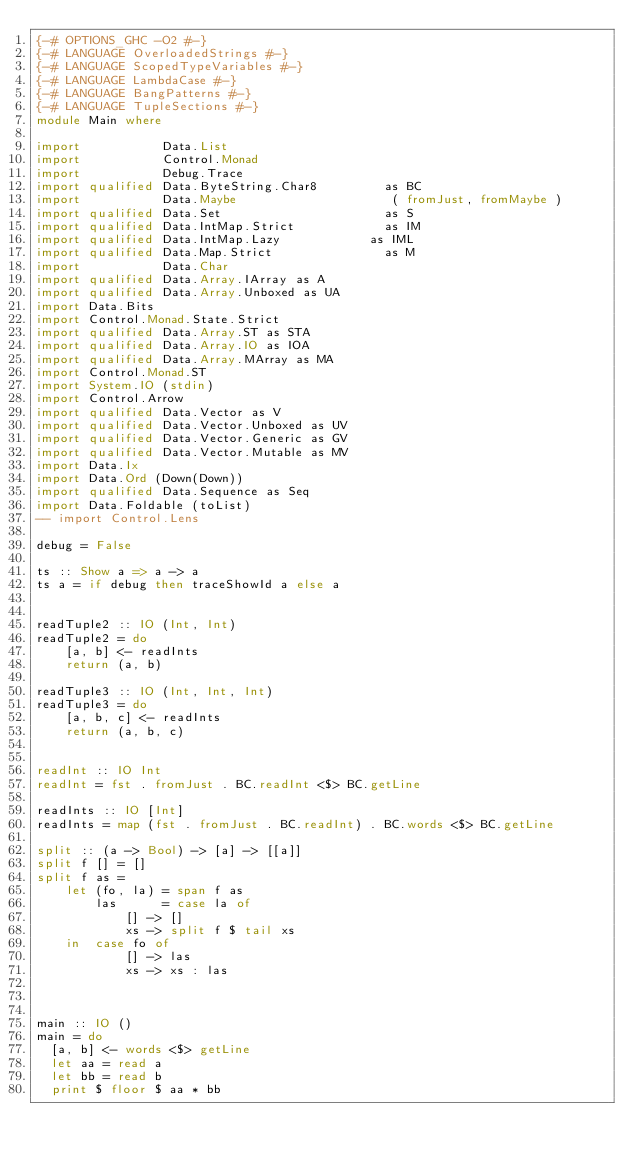Convert code to text. <code><loc_0><loc_0><loc_500><loc_500><_Haskell_>{-# OPTIONS_GHC -O2 #-}
{-# LANGUAGE OverloadedStrings #-}
{-# LANGUAGE ScopedTypeVariables #-}
{-# LANGUAGE LambdaCase #-}
{-# LANGUAGE BangPatterns #-}
{-# LANGUAGE TupleSections #-}
module Main where

import           Data.List
import           Control.Monad
import           Debug.Trace
import qualified Data.ByteString.Char8         as BC
import           Data.Maybe                     ( fromJust, fromMaybe )
import qualified Data.Set                      as S
import qualified Data.IntMap.Strict            as IM
import qualified Data.IntMap.Lazy            as IML
import qualified Data.Map.Strict               as M
import           Data.Char
import qualified Data.Array.IArray as A
import qualified Data.Array.Unboxed as UA
import Data.Bits
import Control.Monad.State.Strict
import qualified Data.Array.ST as STA
import qualified Data.Array.IO as IOA
import qualified Data.Array.MArray as MA
import Control.Monad.ST
import System.IO (stdin)
import Control.Arrow
import qualified Data.Vector as V
import qualified Data.Vector.Unboxed as UV
import qualified Data.Vector.Generic as GV
import qualified Data.Vector.Mutable as MV
import Data.Ix
import Data.Ord (Down(Down))
import qualified Data.Sequence as Seq
import Data.Foldable (toList)
-- import Control.Lens

debug = False

ts :: Show a => a -> a
ts a = if debug then traceShowId a else a


readTuple2 :: IO (Int, Int)
readTuple2 = do
    [a, b] <- readInts
    return (a, b)

readTuple3 :: IO (Int, Int, Int)
readTuple3 = do
    [a, b, c] <- readInts
    return (a, b, c)


readInt :: IO Int
readInt = fst . fromJust . BC.readInt <$> BC.getLine

readInts :: IO [Int]
readInts = map (fst . fromJust . BC.readInt) . BC.words <$> BC.getLine

split :: (a -> Bool) -> [a] -> [[a]]
split f [] = []
split f as =
    let (fo, la) = span f as
        las      = case la of
            [] -> []
            xs -> split f $ tail xs
    in  case fo of
            [] -> las
            xs -> xs : las



main :: IO ()
main = do
  [a, b] <- words <$> getLine
  let aa = read a
  let bb = read b
  print $ floor $ aa * bb


</code> 